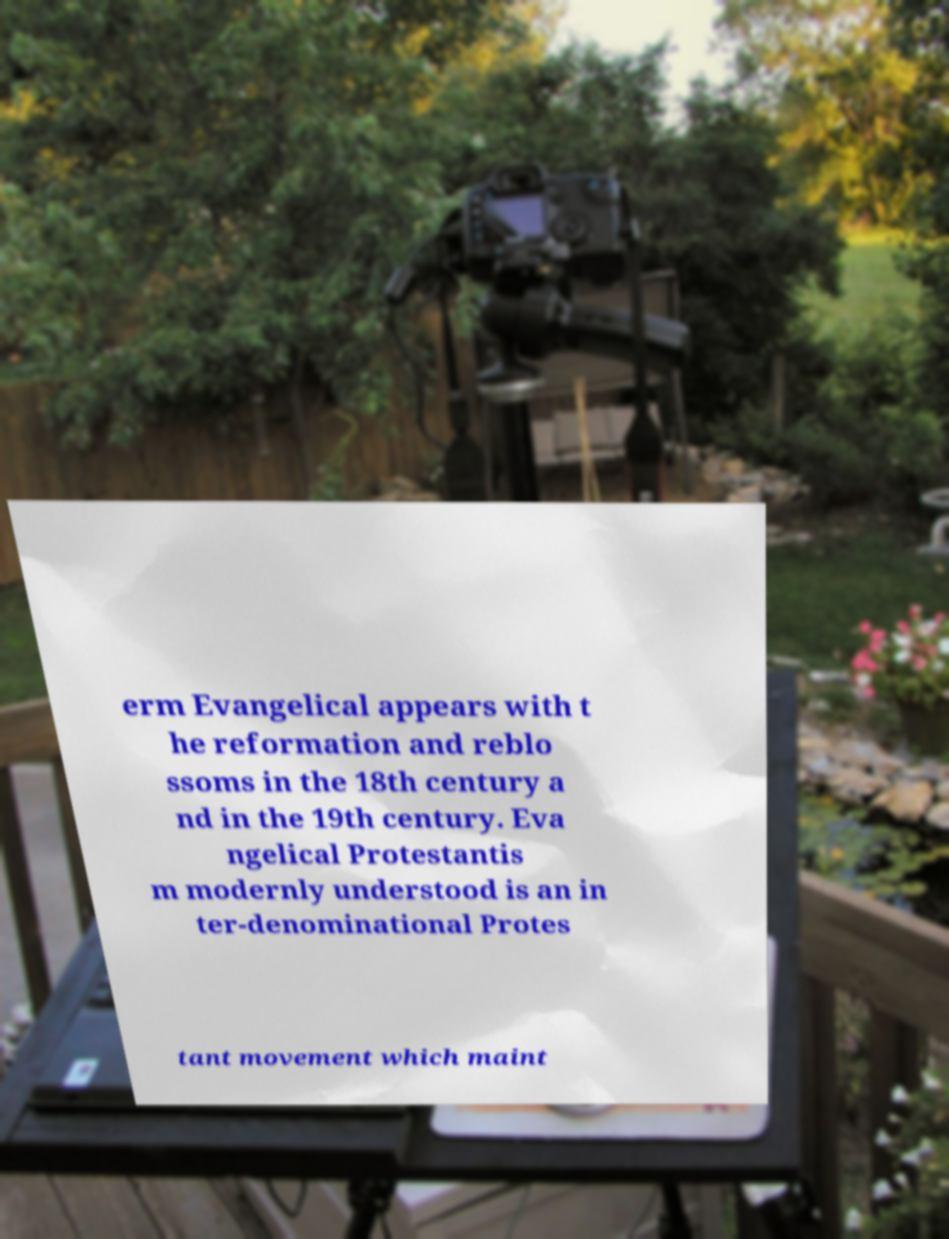There's text embedded in this image that I need extracted. Can you transcribe it verbatim? erm Evangelical appears with t he reformation and reblo ssoms in the 18th century a nd in the 19th century. Eva ngelical Protestantis m modernly understood is an in ter-denominational Protes tant movement which maint 